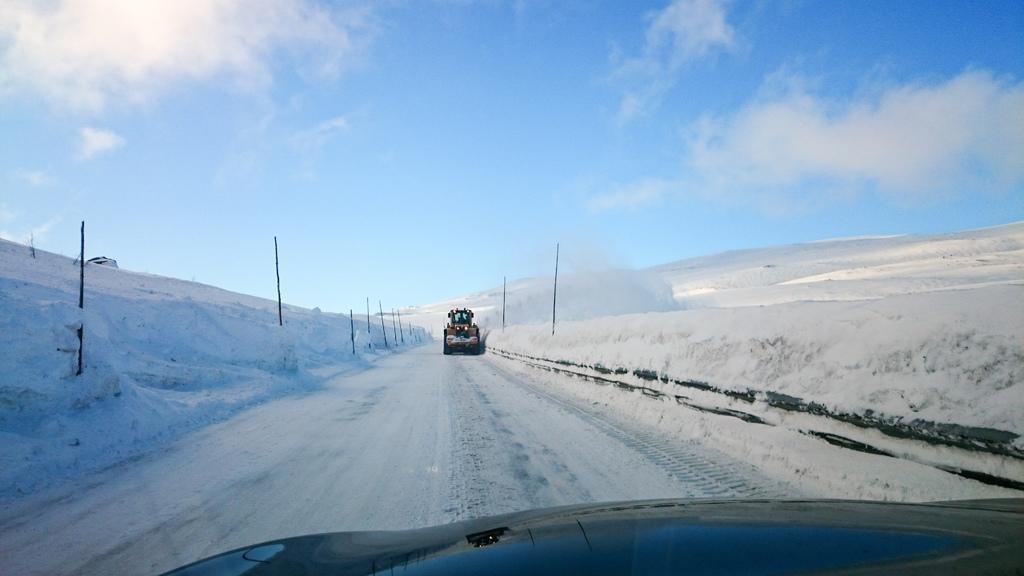Can you describe this image briefly? Here I can see two vehicles on the road. On both sides of the road I can see the snow and some poles. On the top of the image I can see the sky and clouds. 